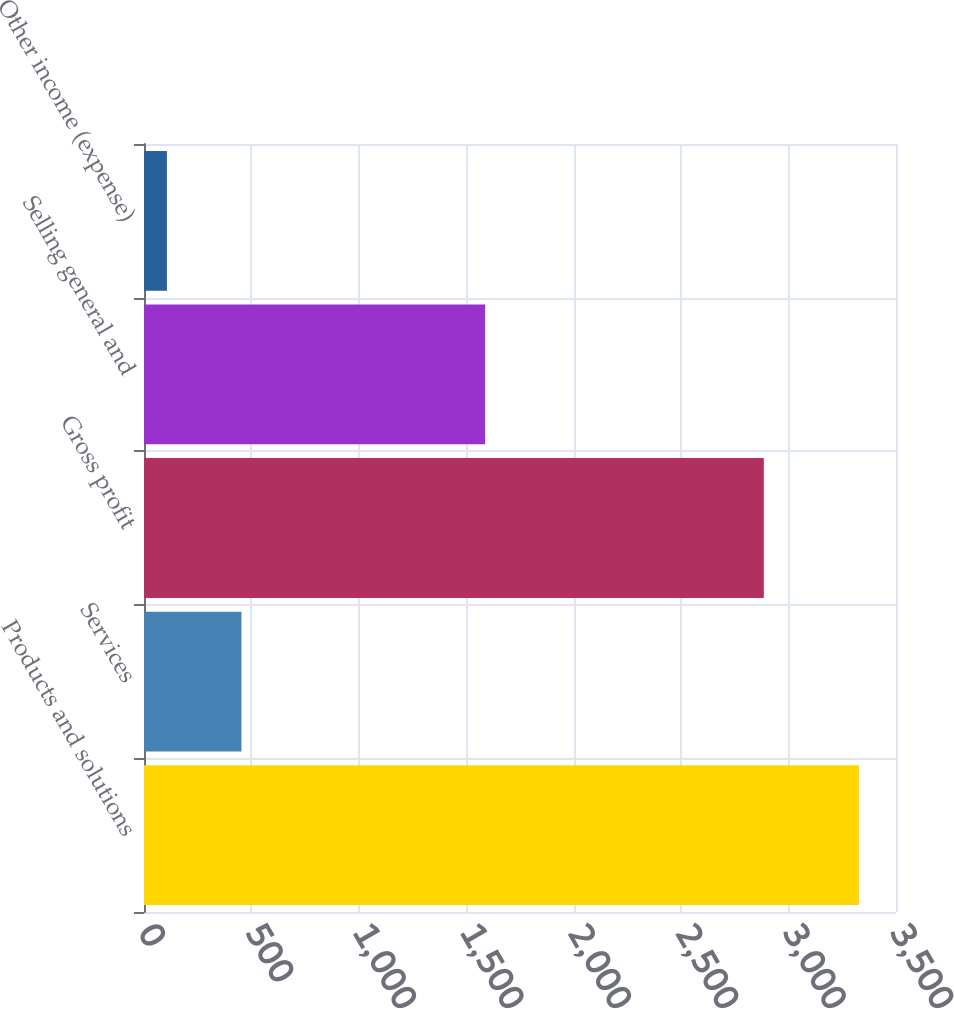Convert chart to OTSL. <chart><loc_0><loc_0><loc_500><loc_500><bar_chart><fcel>Products and solutions<fcel>Services<fcel>Gross profit<fcel>Selling general and<fcel>Other income (expense)<nl><fcel>3327.5<fcel>453.6<fcel>2884.9<fcel>1587.9<fcel>106.8<nl></chart> 